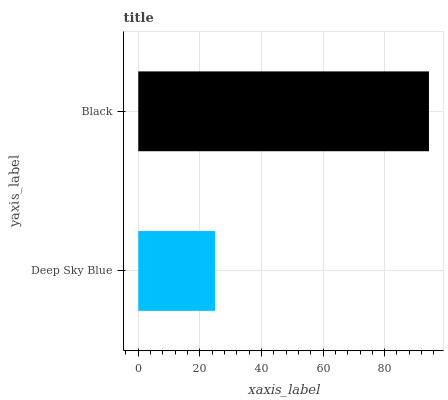Is Deep Sky Blue the minimum?
Answer yes or no. Yes. Is Black the maximum?
Answer yes or no. Yes. Is Black the minimum?
Answer yes or no. No. Is Black greater than Deep Sky Blue?
Answer yes or no. Yes. Is Deep Sky Blue less than Black?
Answer yes or no. Yes. Is Deep Sky Blue greater than Black?
Answer yes or no. No. Is Black less than Deep Sky Blue?
Answer yes or no. No. Is Black the high median?
Answer yes or no. Yes. Is Deep Sky Blue the low median?
Answer yes or no. Yes. Is Deep Sky Blue the high median?
Answer yes or no. No. Is Black the low median?
Answer yes or no. No. 